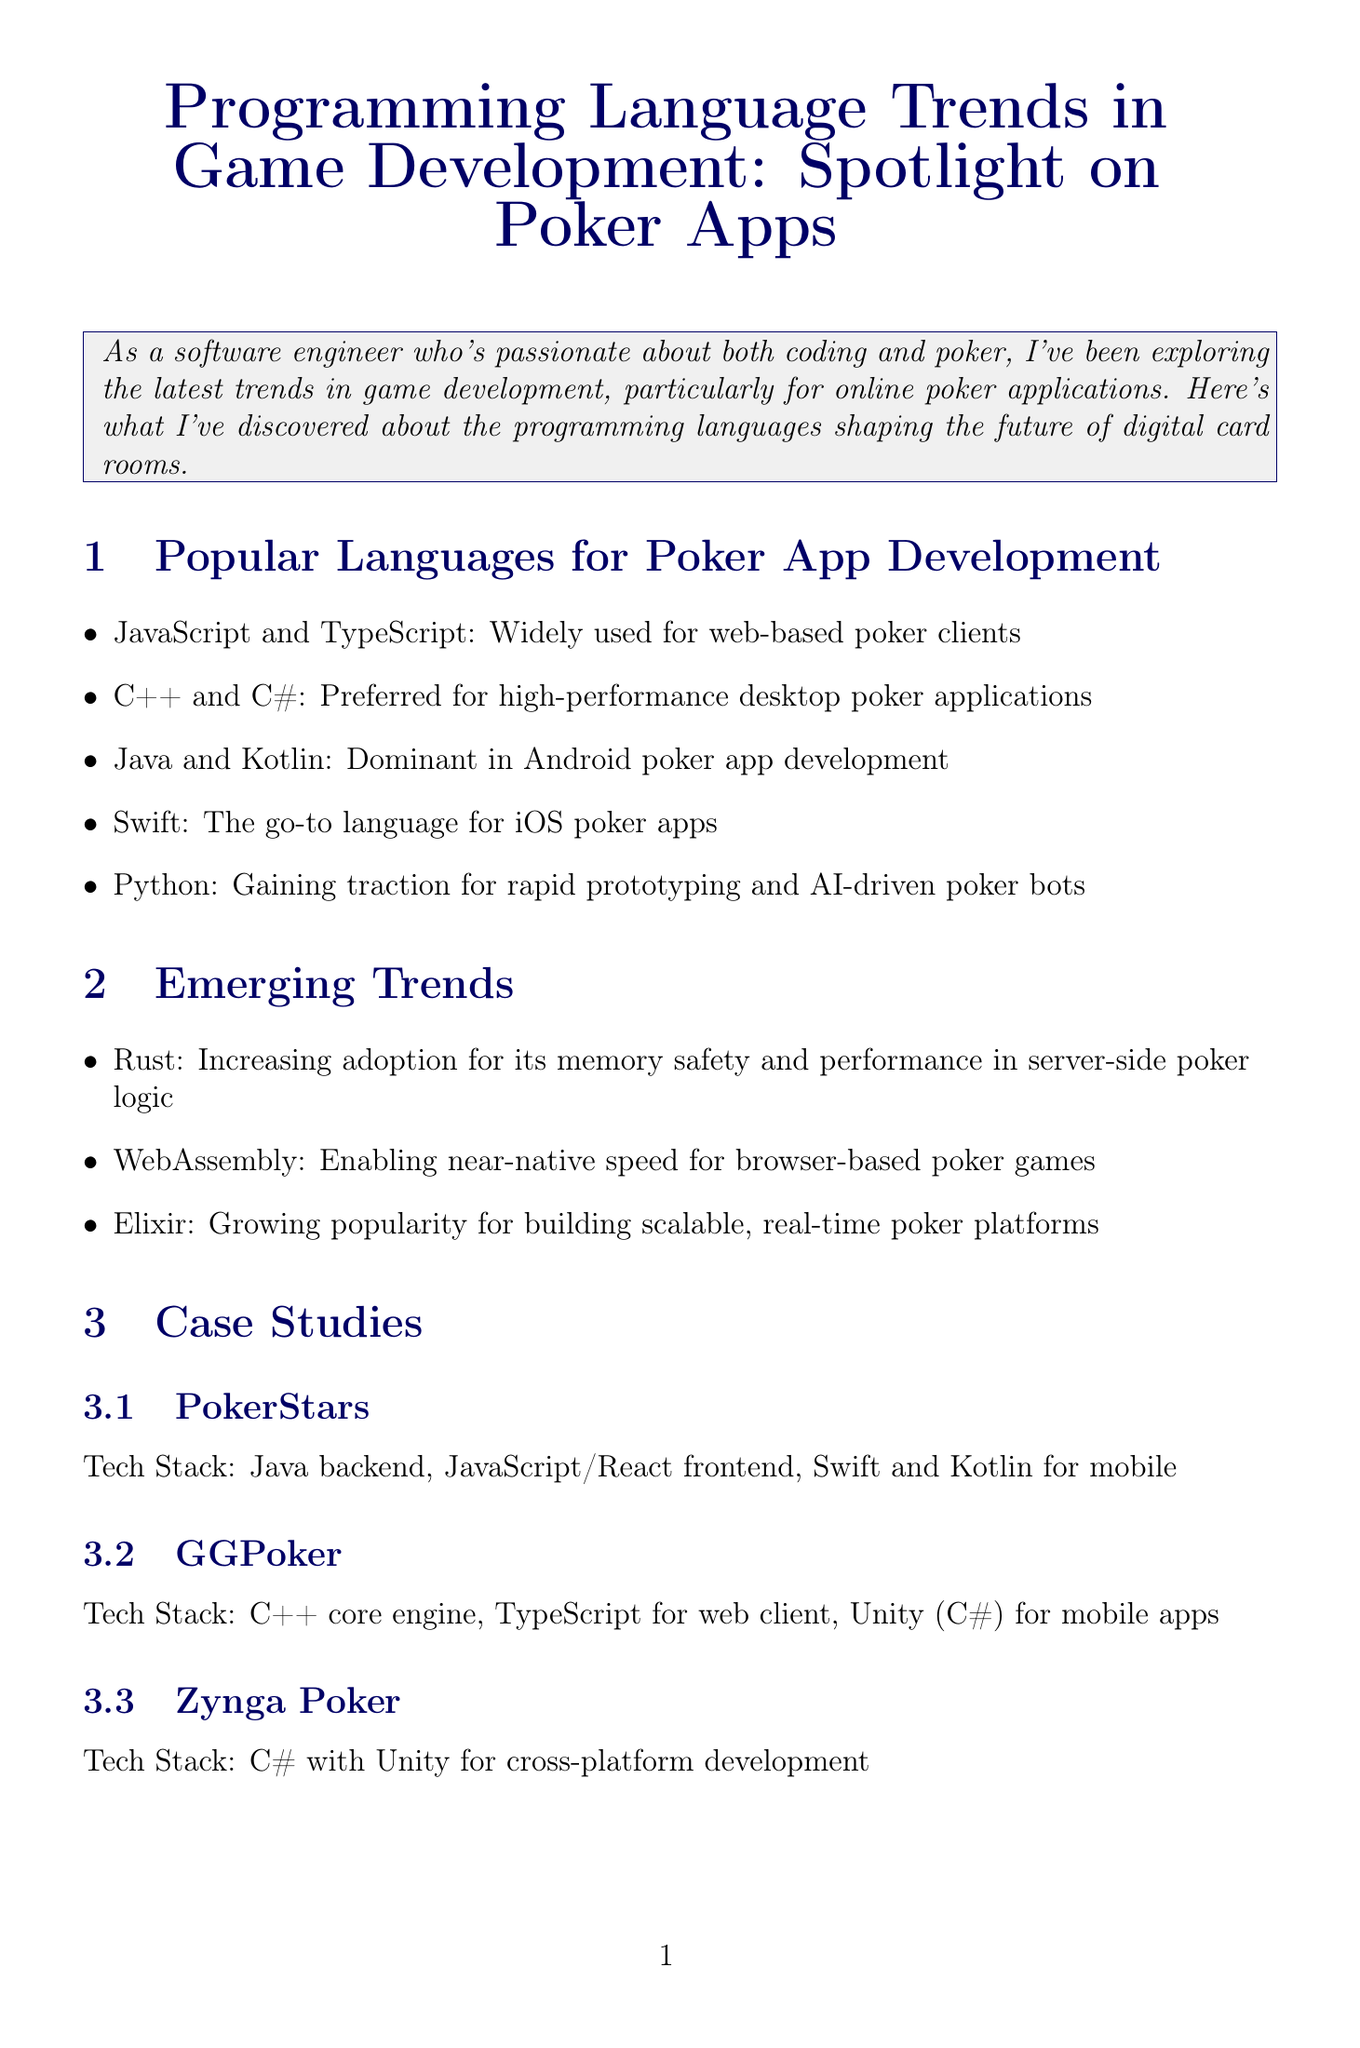What is the newsletter title? The title of the newsletter is presented at the beginning of the document, which is "Programming Language Trends in Game Development: Spotlight on Poker Apps".
Answer: Programming Language Trends in Game Development: Spotlight on Poker Apps Who is the expert quoted in the newsletter? The expert's name and title are mentioned in the "Expert Opinion" section, identifying them as Dr. Jane Chen, a Game Development Researcher at MIT.
Answer: Dr. Jane Chen Which programming language is gaining traction for rapid prototyping and AI-driven poker bots? The document highlights Python as the language that is gaining traction for this purpose in the "Popular Languages for Poker App Development" section.
Answer: Python What is the top discussion in the community insights? The top discussion topic from the TwoPlusTwo Programming subforum is specified in the community insights section: "Debate: Is Rust the future for high-stakes online poker platforms?".
Answer: Debate: Is Rust the future for high-stakes online poker platforms? Which case study company uses C++ for their core engine? The case study section mentions GGPoker, which has C++ as part of its tech stack, specifically for the core engine.
Answer: GGPoker What emerging trend offers near-native speed for browser-based poker games? The newsletter discusses WebAssembly as the trend that enables near-native speed for these types of games in the "Emerging Trends" section.
Answer: WebAssembly What resource is provided for learning to build a poker app with React and TypeScript? A Udemy course titled "Building a Poker App with React and TypeScript" is listed as a resource in the document, including its direct URL.
Answer: Building a Poker App with React and TypeScript What are the key points discussed in the forum regarding Rust? The document cites three major points on Rust: its memory safety, the learning curve for startups, and its performance benefits during major tournaments.
Answer: Memory safety, learning curve, performance benefits 